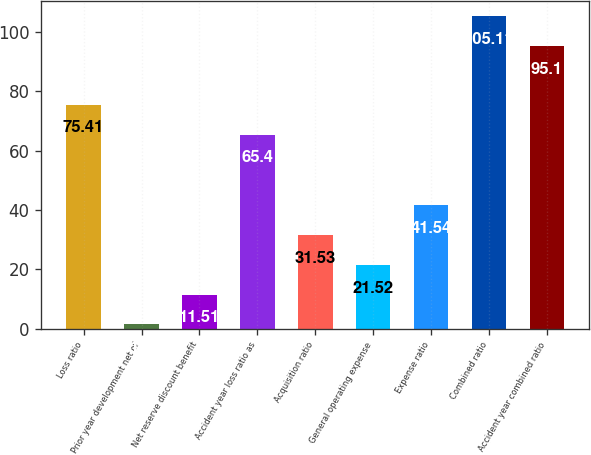Convert chart to OTSL. <chart><loc_0><loc_0><loc_500><loc_500><bar_chart><fcel>Loss ratio<fcel>Prior year development net of<fcel>Net reserve discount benefit<fcel>Accident year loss ratio as<fcel>Acquisition ratio<fcel>General operating expense<fcel>Expense ratio<fcel>Combined ratio<fcel>Accident year combined ratio<nl><fcel>75.41<fcel>1.5<fcel>11.51<fcel>65.4<fcel>31.53<fcel>21.52<fcel>41.54<fcel>105.11<fcel>95.1<nl></chart> 